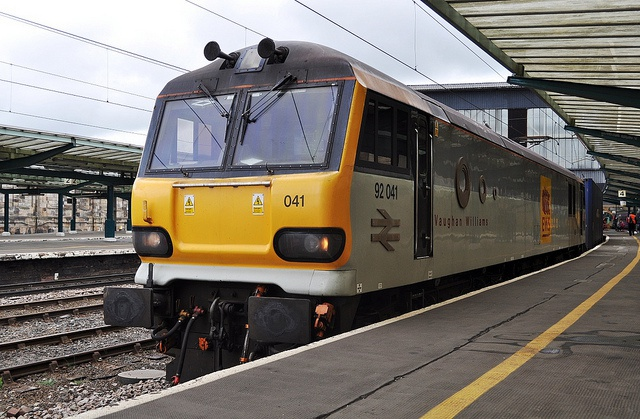Describe the objects in this image and their specific colors. I can see train in white, black, gray, darkgray, and orange tones, people in white, black, maroon, gray, and brown tones, and people in white, black, maroon, purple, and gray tones in this image. 